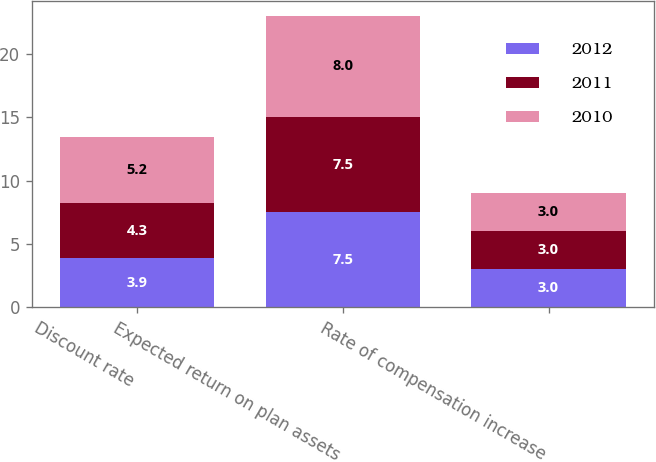<chart> <loc_0><loc_0><loc_500><loc_500><stacked_bar_chart><ecel><fcel>Discount rate<fcel>Expected return on plan assets<fcel>Rate of compensation increase<nl><fcel>2012<fcel>3.9<fcel>7.5<fcel>3<nl><fcel>2011<fcel>4.3<fcel>7.5<fcel>3<nl><fcel>2010<fcel>5.2<fcel>8<fcel>3<nl></chart> 